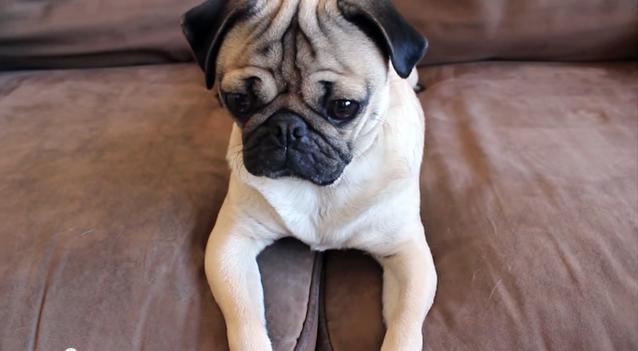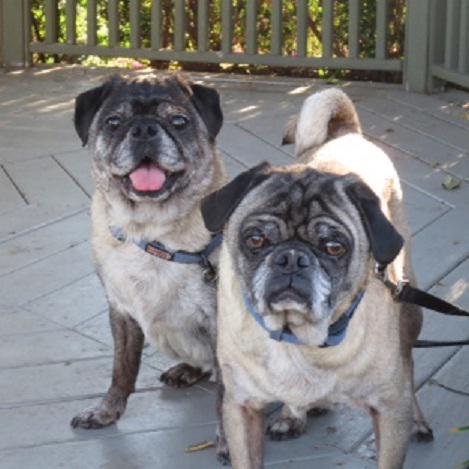The first image is the image on the left, the second image is the image on the right. Examine the images to the left and right. Is the description "There are at most two dogs." accurate? Answer yes or no. No. The first image is the image on the left, the second image is the image on the right. For the images shown, is this caption "There is a single pug in each image." true? Answer yes or no. No. 